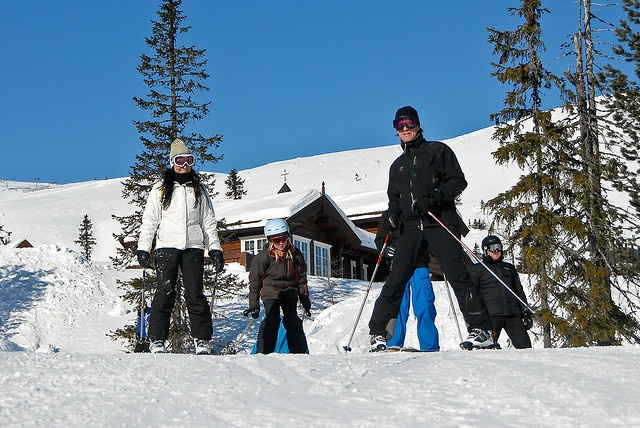Describe the objects in this image and their specific colors. I can see people in gray, black, lightgray, and darkgray tones, people in gray, black, white, and darkgray tones, people in gray, black, lightgray, and maroon tones, people in gray, black, white, and darkgray tones, and people in gray, blue, navy, and black tones in this image. 